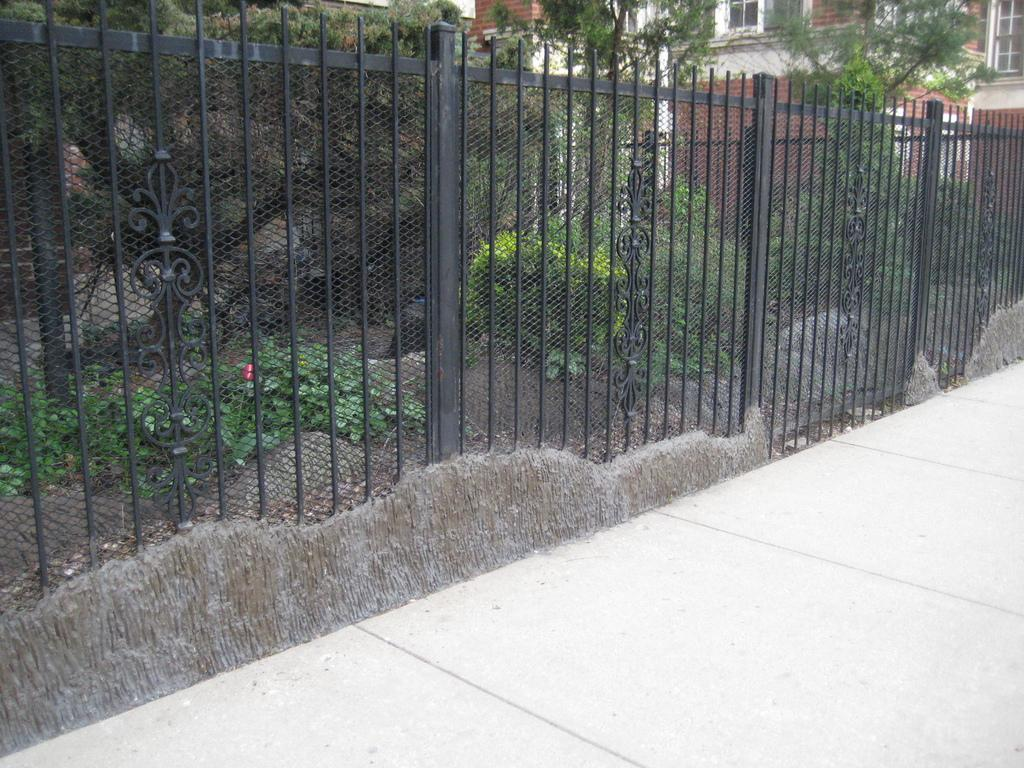What is located in the middle of the image? There is a fencing in the middle of the image. What can be seen behind the fencing? There are plants behind the fencing. What is located behind the plants? There are trees behind the plants. What is situated behind the trees? There is a building behind the trees. What type of toothpaste is being used to clean the plants in the image? There is no toothpaste present in the image, and plants do not require cleaning with toothpaste. 